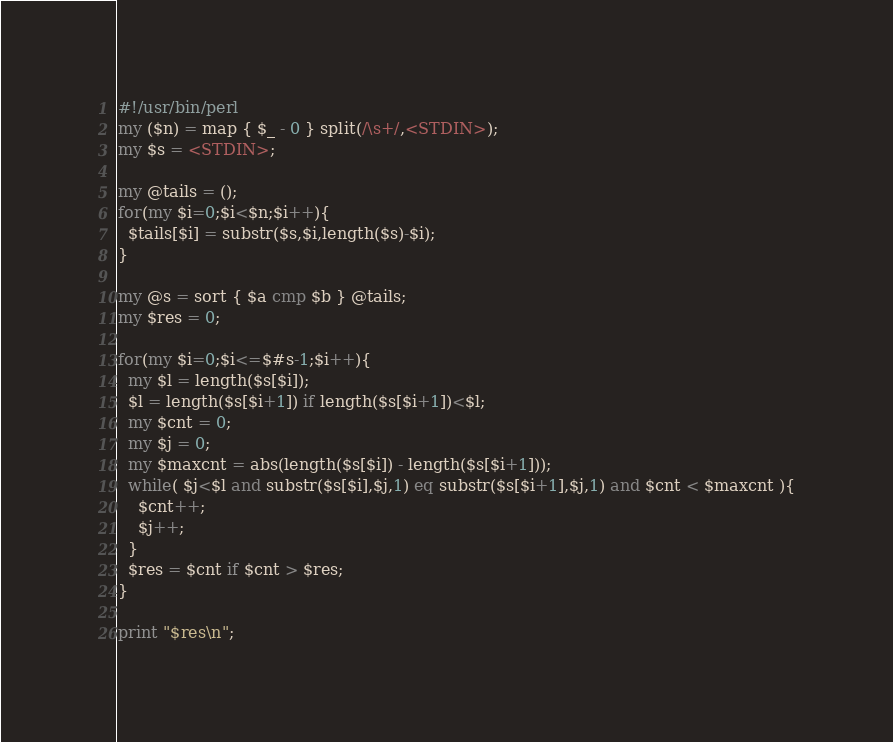<code> <loc_0><loc_0><loc_500><loc_500><_Perl_>#!/usr/bin/perl
my ($n) = map { $_ - 0 } split(/\s+/,<STDIN>);
my $s = <STDIN>;

my @tails = ();
for(my $i=0;$i<$n;$i++){
  $tails[$i] = substr($s,$i,length($s)-$i);
}

my @s = sort { $a cmp $b } @tails;
my $res = 0;

for(my $i=0;$i<=$#s-1;$i++){
  my $l = length($s[$i]);
  $l = length($s[$i+1]) if length($s[$i+1])<$l;
  my $cnt = 0;
  my $j = 0;
  my $maxcnt = abs(length($s[$i]) - length($s[$i+1]));
  while( $j<$l and substr($s[$i],$j,1) eq substr($s[$i+1],$j,1) and $cnt < $maxcnt ){
    $cnt++;
    $j++;
  }
  $res = $cnt if $cnt > $res;
}

print "$res\n";

</code> 